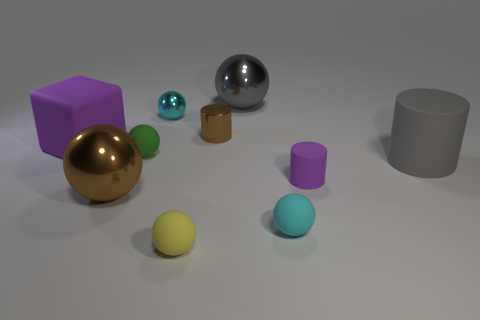Subtract all gray cylinders. How many cylinders are left? 2 Subtract all cyan balls. How many purple cylinders are left? 1 Subtract all green balls. How many balls are left? 5 Subtract all cubes. How many objects are left? 9 Subtract 2 cylinders. How many cylinders are left? 1 Subtract all blue cylinders. Subtract all purple blocks. How many cylinders are left? 3 Subtract all gray balls. Subtract all gray cylinders. How many objects are left? 8 Add 2 purple rubber cylinders. How many purple rubber cylinders are left? 3 Add 8 big cylinders. How many big cylinders exist? 9 Subtract 1 purple cylinders. How many objects are left? 9 